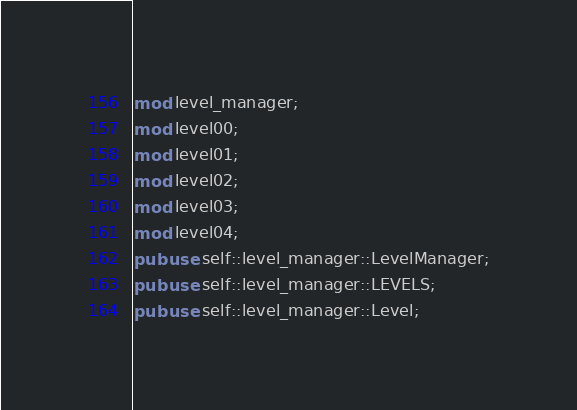Convert code to text. <code><loc_0><loc_0><loc_500><loc_500><_Rust_>mod level_manager;
mod level00;
mod level01;
mod level02;
mod level03;
mod level04;
pub use self::level_manager::LevelManager;
pub use self::level_manager::LEVELS;
pub use self::level_manager::Level;</code> 